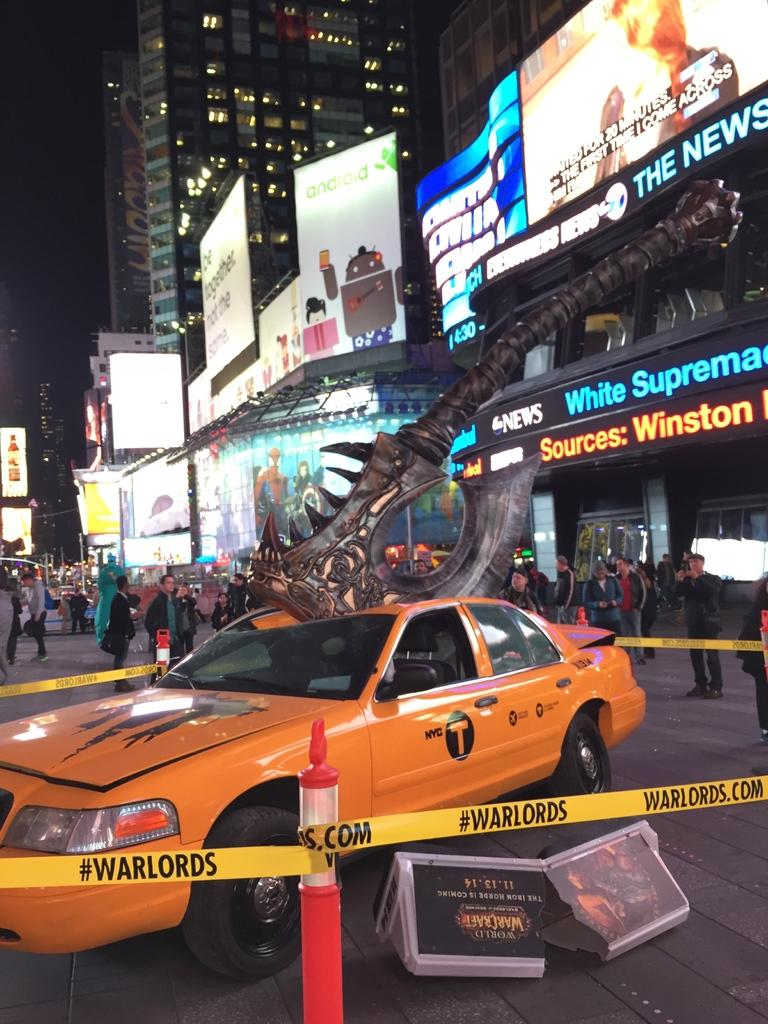<image>
Provide a brief description of the given image. A taxi that has been smashed by a huge axe is surrounded by yellow caution tape that says #Warlords on it. 